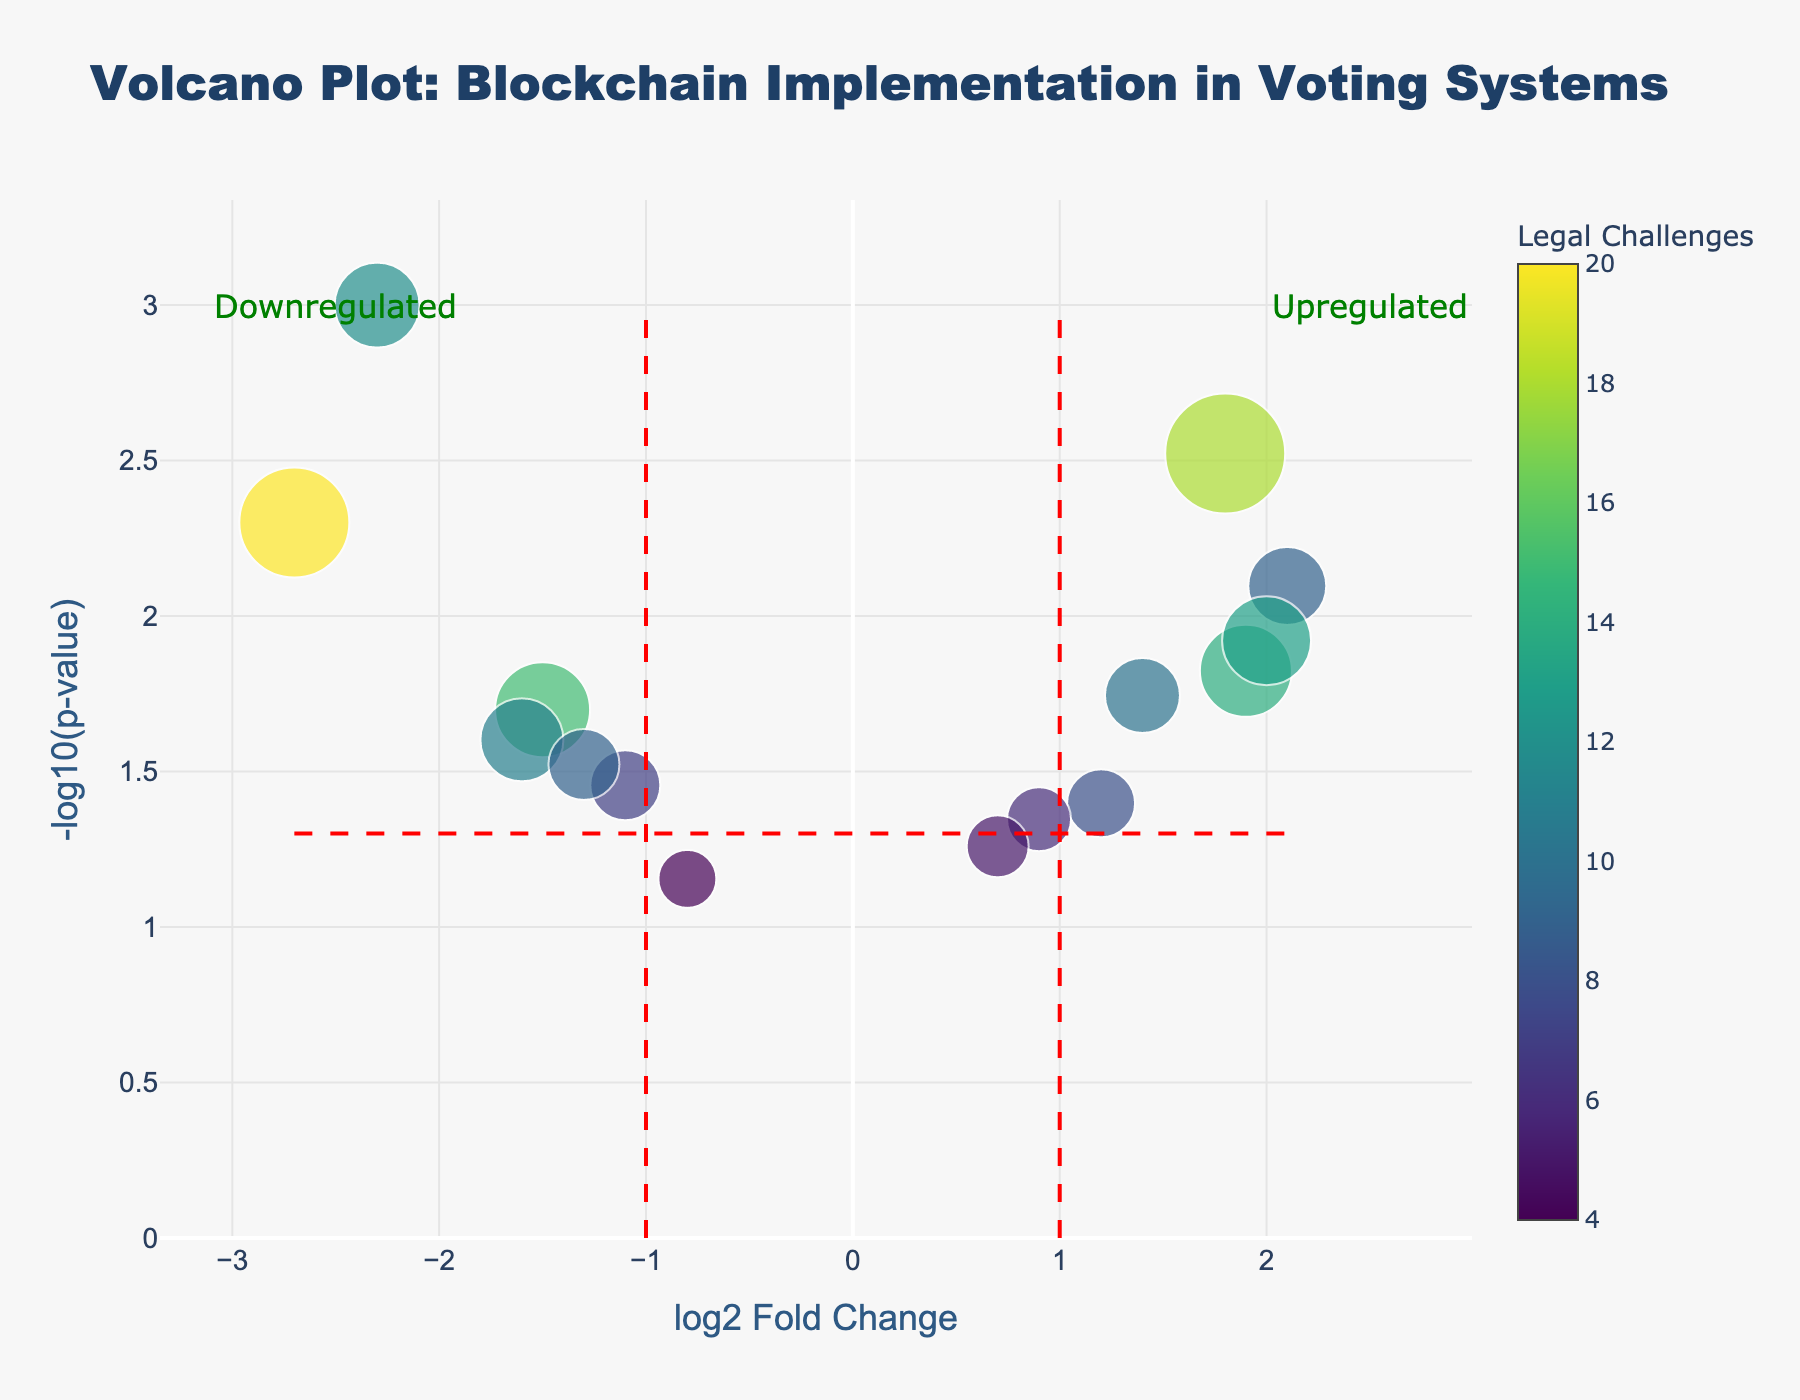What is the title of the figure? The title of the figure is displayed at the top center and reads "Volcano Plot: Blockchain Implementation in Voting Systems".
Answer: Volcano Plot: Blockchain Implementation in Voting Systems What is the y-axis representing? The y-axis represents the negative logarithm (base 10) of the p-value, denoted as -log10(p-value).
Answer: -log10(p-value) How many districts are visually represented in the plot? Each data point corresponds to a district, and counting the points, we see that there are 15 districts represented.
Answer: 15 Which districts have a log2 Fold Change greater than 1? By looking to the right of the vertical line at log2 Fold Change = 1, we observe that King County, Miami-Dade County, Travis County, Cook County, and Fulton County have values greater than 1.
Answer: King County, Miami-Dade County, Travis County, Cook County, Fulton County Which district has the highest number of legal challenges? The color scale indicates legal challenges, with the highest value being 20. Therefore, the district with 20 legal challenges is Harris County.
Answer: Harris County What is the p-value threshold indicated by the horizontal red dashed line? The red dashed line represents the p-value threshold at y = -log10(0.05), which translates to p = 0.05.
Answer: 0.05 Which districts are considered "upregulated" based on log2 Fold Change? Districts with log2 Fold Change greater than 1 are considered "upregulated". From the plot, these districts include King County, Miami-Dade County, Travis County, and Cook County.
Answer: King County, Miami-Dade County, Travis County, Cook County Which district has the lowest implementation cost, and what is its log2 Fold Change? Looking at the size of the points, the smallest point corresponds to Suffolk County, which has the lowest implementation cost. The x-value (log2 Fold Change) for this district is approximately -0.8.
Answer: Suffolk County, -0.8 Which district has the smallest p-value, and what is its corresponding log2 Fold Change? The highest point on the y-axis represents the smallest p-value. This corresponds to San Francisco, which has a log2 Fold Change of approximately -2.3.
Answer: San Francisco, -2.3 